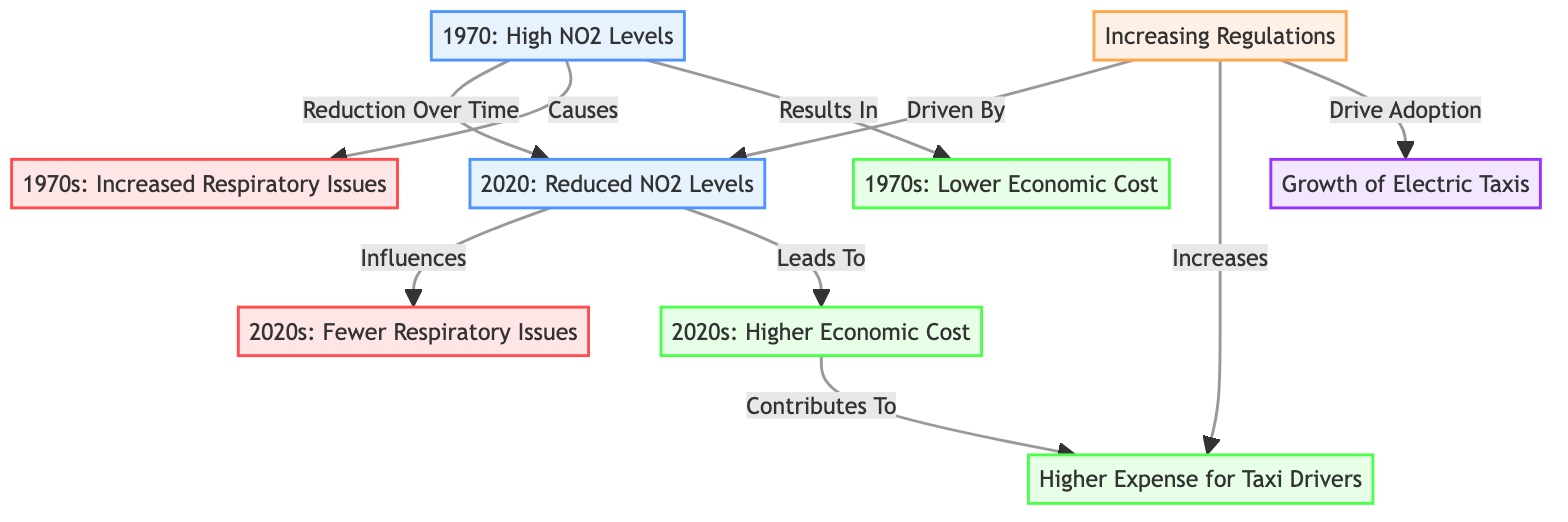What were the NO2 levels in 1970? The diagram indicates that the NO2 levels were "High" in 1970, showing a direct connection from the 1970_NO2 node.
Answer: High What health impact is linked to 1970? The diagram connects the 1970_NO2 node to "Increased Respiratory Issues," indicating this as a related health impact.
Answer: Increased Respiratory Issues What is the economic cost situation in the 2020s? The ECON_2020s node shows "Higher Economic Cost," indicating that economic costs have risen compared to previous years.
Answer: Higher Economic Cost How do regulations affect electric taxis? The REGS node states that regulations "Drive Adoption" of electric taxis, indicating a positive influence of regulations on their growth.
Answer: Drive Adoption What led to fewer respiratory issues in the 2020s? The diagram shows that the reduction in NO2 levels from 2020_NO2 influences the health outcome leading to "Fewer Respiratory Issues," establishing a cause-and-effect relationship.
Answer: Reduction in NO2 How many nodes are linked to regulatory changes? The REGS node connects to three other nodes: TAX, 2020_NO2, and ELEC_TAXIS, indicating that there are three nodes associated with regulatory changes.
Answer: 3 What was the economic cost in the 1970s? The diagram indicates that in the 1970s, the economic cost was "Lower," providing a clear understanding of the economic situation at that time.
Answer: Lower What is the relationship between regulations and taxi expenses? The REGS node links to TAX with an indication that regulations "Increases" taxi expenses, demonstrating a direct causal relationship between regulations and costs for taxi drivers.
Answer: Increases What has driven the increase in electric taxis? The diagram indicates that the rise of electric taxis is "Driven By" increasing regulations, forming a cause-and-effect connection in the flow of information.
Answer: Driven By 